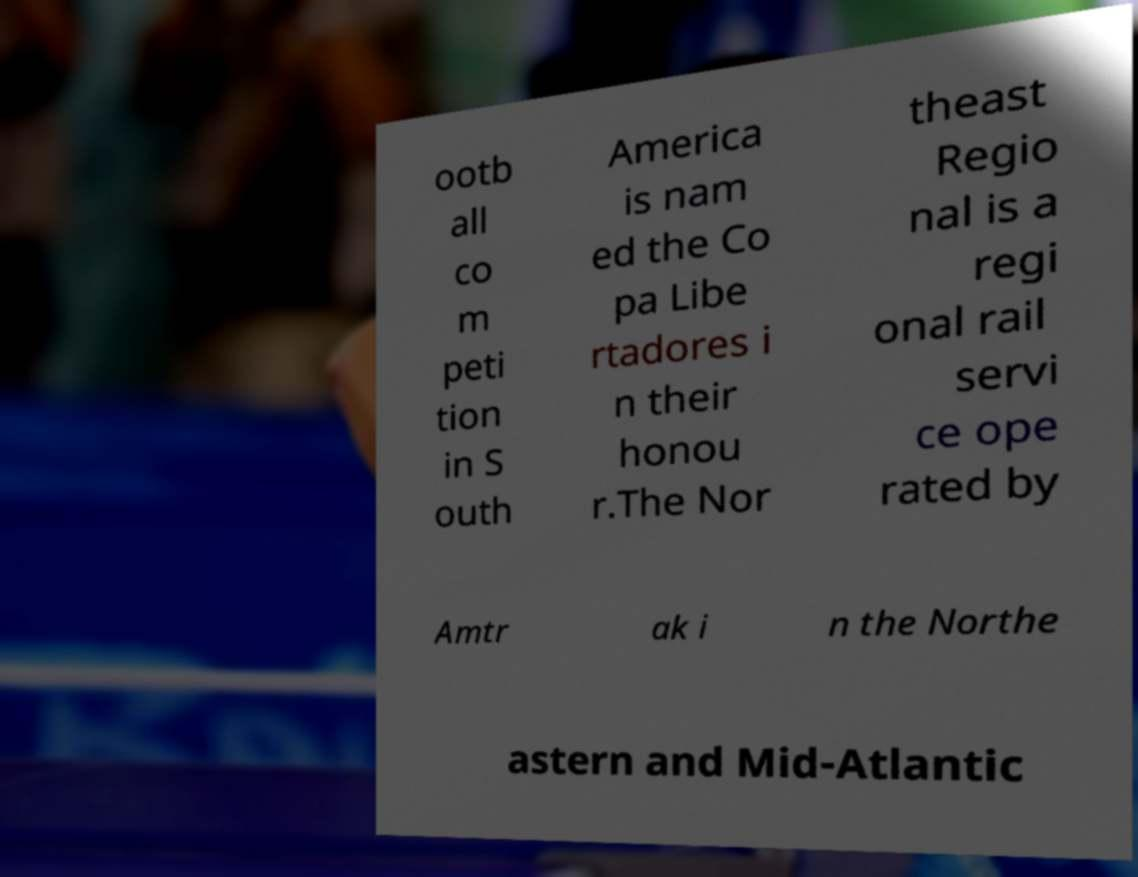Please identify and transcribe the text found in this image. ootb all co m peti tion in S outh America is nam ed the Co pa Libe rtadores i n their honou r.The Nor theast Regio nal is a regi onal rail servi ce ope rated by Amtr ak i n the Northe astern and Mid-Atlantic 